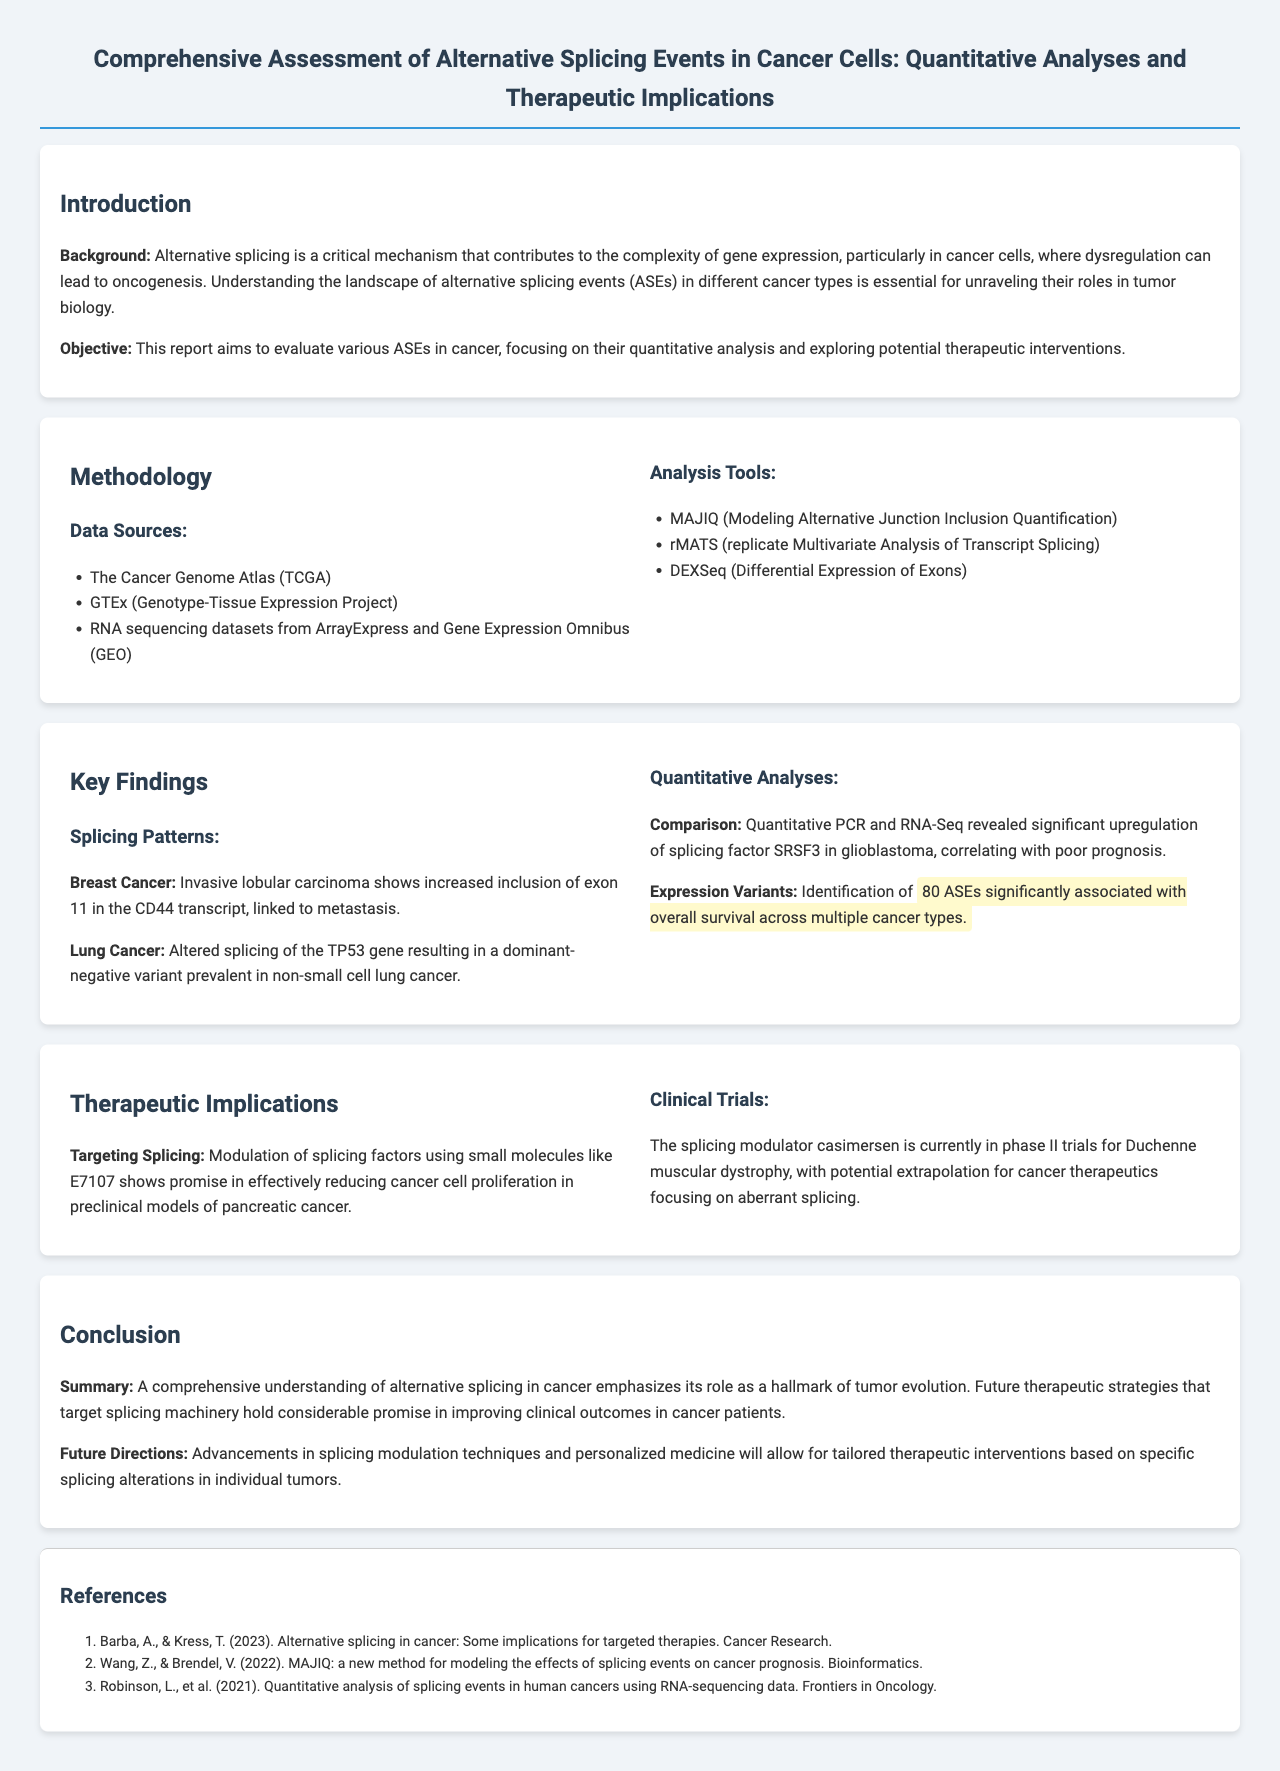What are the data sources used in the methodology? The data sources include The Cancer Genome Atlas, GTEx, and RNA sequencing datasets from ArrayExpress and Gene Expression Omnibus.
Answer: The Cancer Genome Atlas, GTEx, RNA sequencing datasets from ArrayExpress and Gene Expression Omnibus What splicing factor was significantly upregulated in glioblastoma? The document highlights that SRSF3 was significantly upregulated in glioblastoma.
Answer: SRSF3 How many alternative splicing events are significantly associated with overall survival? The analysis identifies 80 alternative splicing events significantly associated with overall survival across multiple cancer types.
Answer: 80 What therapeutic strategy shows promise against cancer cell proliferation? The modulation of splicing factors using small molecules like E7107 shows promise in reducing cancer cell proliferation.
Answer: E7107 What is the phase of the clinical trial for the splicing modulator casimersen? The document states that casimersen is currently in phase II trials.
Answer: Phase II 